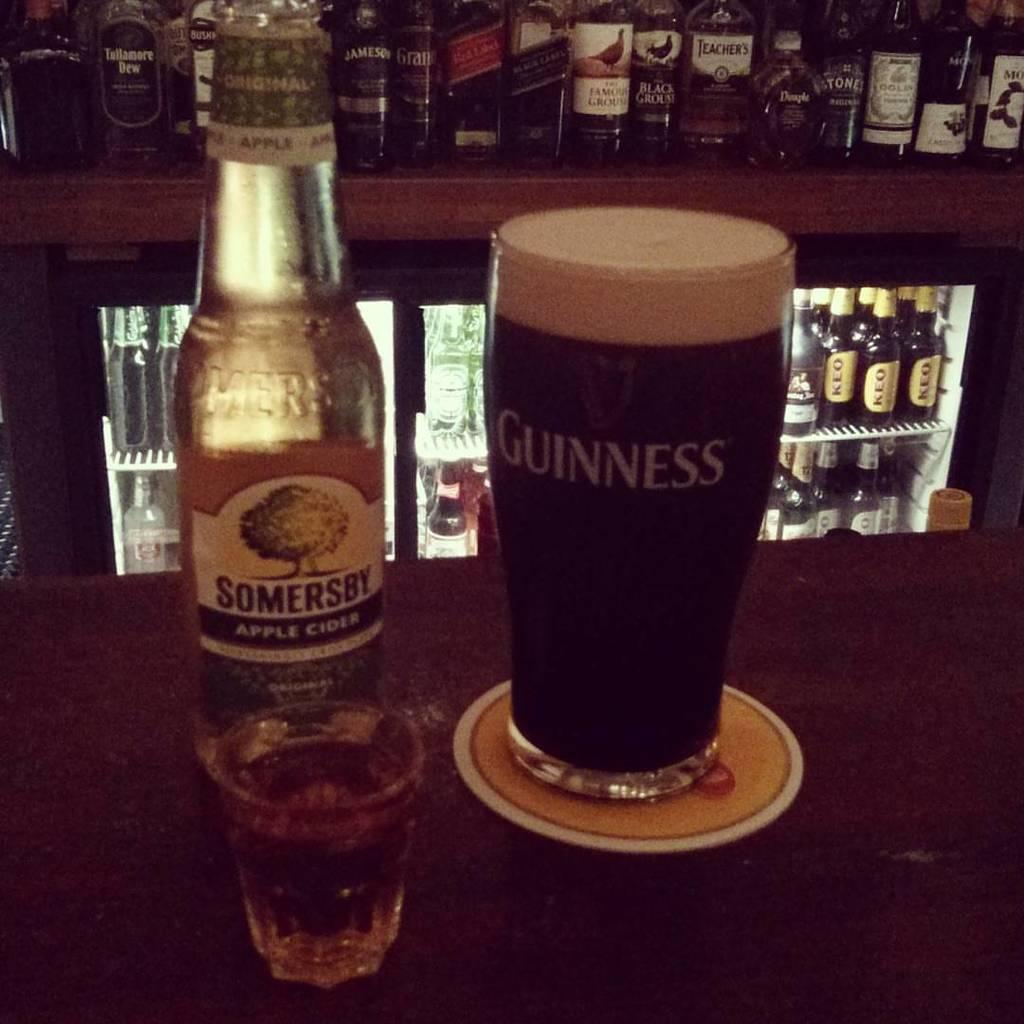Provide a one-sentence caption for the provided image. A guinness glass filled with a beer sits on a coaster. 